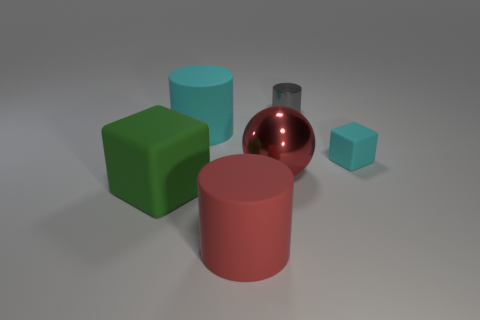Subtract all gray cylinders. How many cylinders are left? 2 Add 3 cubes. How many objects exist? 9 Subtract all balls. How many objects are left? 5 Subtract 0 blue cylinders. How many objects are left? 6 Subtract all big cyan things. Subtract all big yellow blocks. How many objects are left? 5 Add 2 gray things. How many gray things are left? 3 Add 2 big cyan cubes. How many big cyan cubes exist? 2 